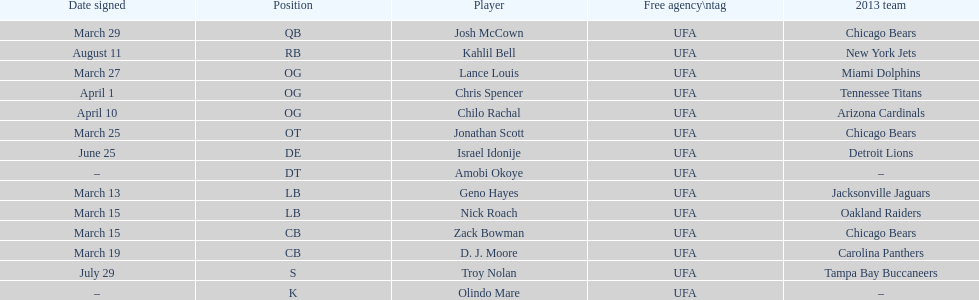Would you mind parsing the complete table? {'header': ['Date signed', 'Position', 'Player', 'Free agency\\ntag', '2013 team'], 'rows': [['March 29', 'QB', 'Josh McCown', 'UFA', 'Chicago Bears'], ['August 11', 'RB', 'Kahlil Bell', 'UFA', 'New York Jets'], ['March 27', 'OG', 'Lance Louis', 'UFA', 'Miami Dolphins'], ['April 1', 'OG', 'Chris Spencer', 'UFA', 'Tennessee Titans'], ['April 10', 'OG', 'Chilo Rachal', 'UFA', 'Arizona Cardinals'], ['March 25', 'OT', 'Jonathan Scott', 'UFA', 'Chicago Bears'], ['June 25', 'DE', 'Israel Idonije', 'UFA', 'Detroit Lions'], ['–', 'DT', 'Amobi Okoye', 'UFA', '–'], ['March 13', 'LB', 'Geno Hayes', 'UFA', 'Jacksonville Jaguars'], ['March 15', 'LB', 'Nick Roach', 'UFA', 'Oakland Raiders'], ['March 15', 'CB', 'Zack Bowman', 'UFA', 'Chicago Bears'], ['March 19', 'CB', 'D. J. Moore', 'UFA', 'Carolina Panthers'], ['July 29', 'S', 'Troy Nolan', 'UFA', 'Tampa Bay Buccaneers'], ['–', 'K', 'Olindo Mare', 'UFA', '–']]} His/her first name is the same name as a country. Israel Idonije. 